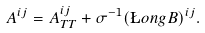<formula> <loc_0><loc_0><loc_500><loc_500>A ^ { i j } = A ^ { i j } _ { T T } + \sigma ^ { - 1 } ( \L o n g B ) ^ { i j } .</formula> 